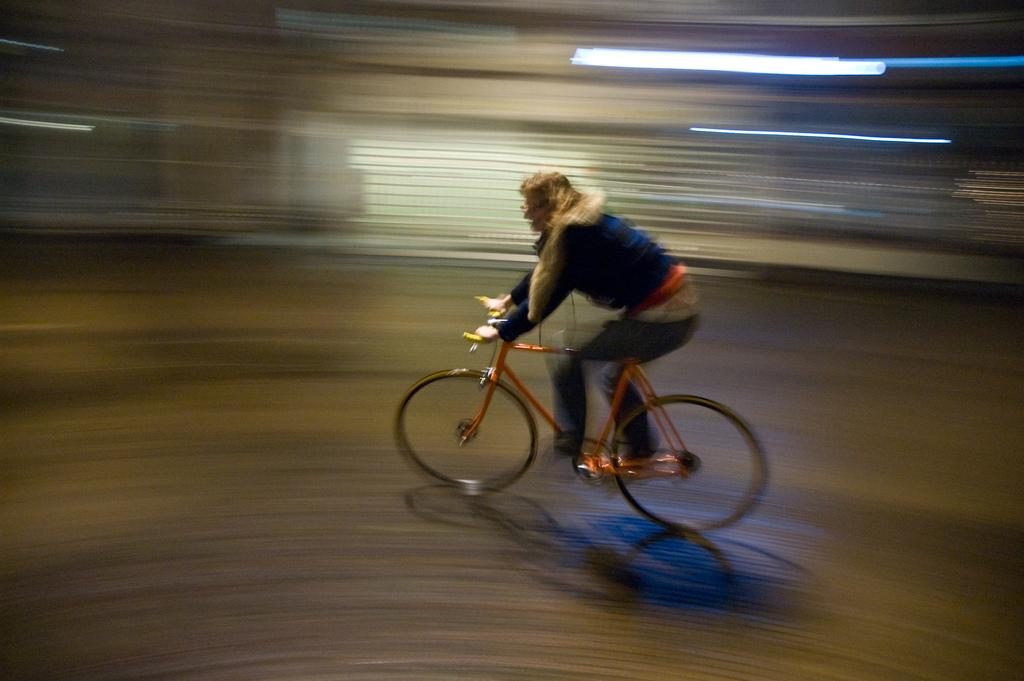What is the main subject of the image? There is a person in the image. What is the person doing in the image? The person is riding a bicycle. What type of watch is the person wearing while riding the bicycle in the image? There is no watch visible in the image, and the person's attire is not described. 